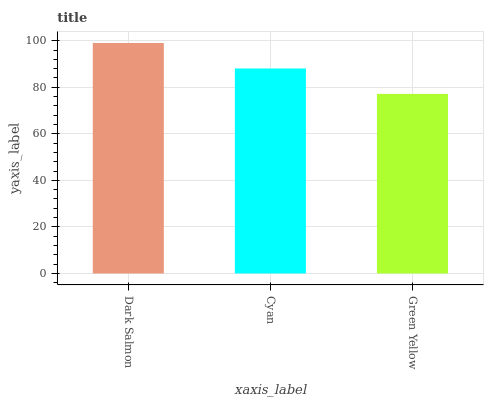Is Green Yellow the minimum?
Answer yes or no. Yes. Is Dark Salmon the maximum?
Answer yes or no. Yes. Is Cyan the minimum?
Answer yes or no. No. Is Cyan the maximum?
Answer yes or no. No. Is Dark Salmon greater than Cyan?
Answer yes or no. Yes. Is Cyan less than Dark Salmon?
Answer yes or no. Yes. Is Cyan greater than Dark Salmon?
Answer yes or no. No. Is Dark Salmon less than Cyan?
Answer yes or no. No. Is Cyan the high median?
Answer yes or no. Yes. Is Cyan the low median?
Answer yes or no. Yes. Is Dark Salmon the high median?
Answer yes or no. No. Is Dark Salmon the low median?
Answer yes or no. No. 